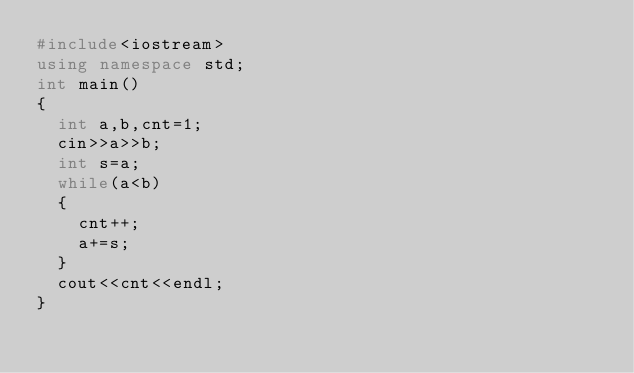Convert code to text. <code><loc_0><loc_0><loc_500><loc_500><_C++_>#include<iostream>
using namespace std;
int main()
{
  int a,b,cnt=1;
  cin>>a>>b;
  int s=a;
  while(a<b)
  {
    cnt++;
    a+=s;
  }
  cout<<cnt<<endl;
}</code> 